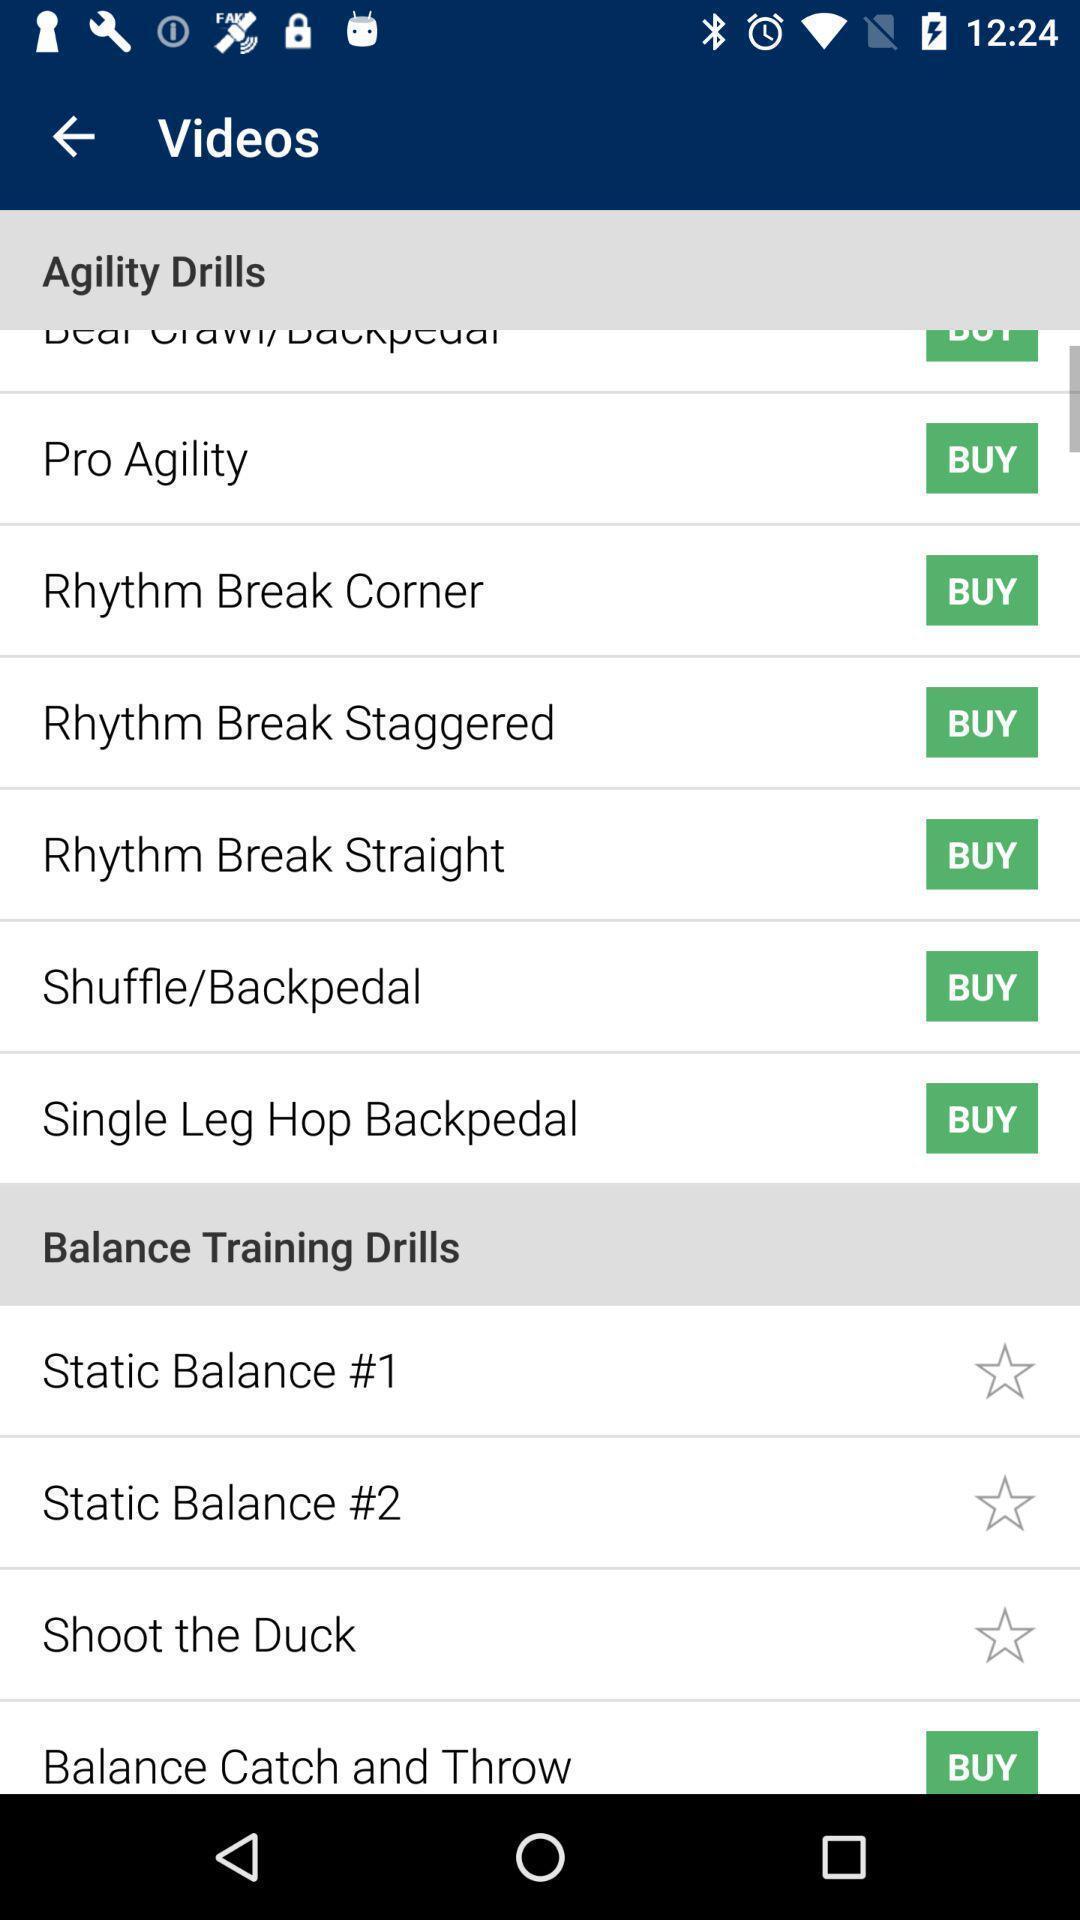Explain the elements present in this screenshot. Screen is showing agility drills with buy options in application. 